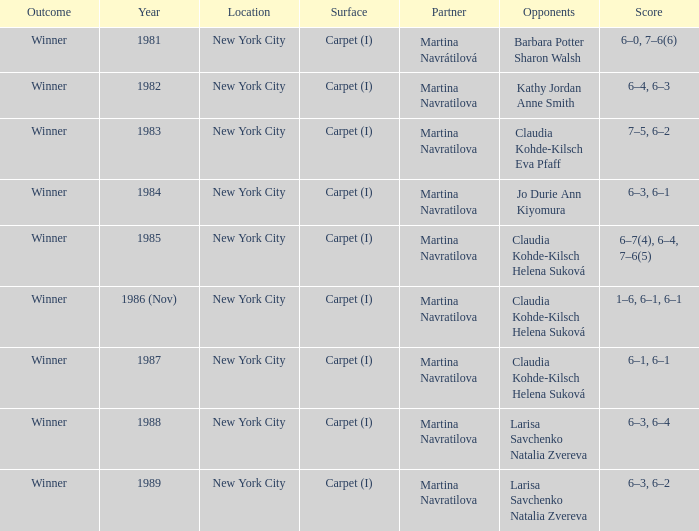Who were all of the opponents in 1984? Jo Durie Ann Kiyomura. 